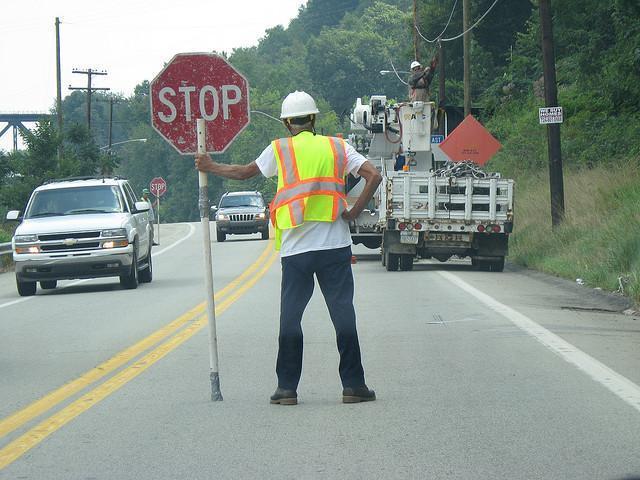How many cars are in the photo?
Give a very brief answer. 2. How many trucks are in the picture?
Give a very brief answer. 3. How many people can be seen?
Give a very brief answer. 1. 